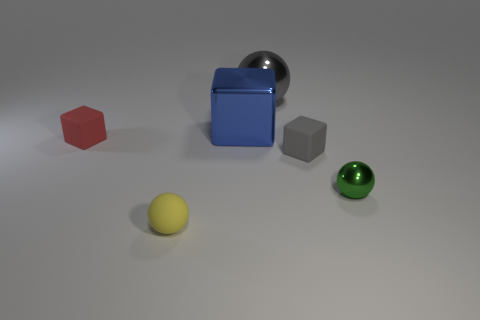What number of big blue objects are right of the matte ball?
Your answer should be very brief. 1. Is there a tiny cyan cylinder that has the same material as the tiny green thing?
Your answer should be very brief. No. There is a yellow sphere that is the same size as the green sphere; what is its material?
Your answer should be compact. Rubber. There is a ball that is in front of the large gray object and behind the yellow thing; what size is it?
Provide a succinct answer. Small. What color is the small object that is both in front of the tiny red rubber thing and left of the big blue block?
Ensure brevity in your answer.  Yellow. Is the number of small balls that are to the left of the big ball less than the number of small red matte things behind the small shiny thing?
Give a very brief answer. No. How many other gray rubber objects have the same shape as the big gray thing?
Ensure brevity in your answer.  0. What is the size of the red block that is made of the same material as the small gray block?
Your answer should be very brief. Small. What is the color of the block on the right side of the big gray metallic thing that is behind the red thing?
Provide a short and direct response. Gray. Does the green metal object have the same shape as the tiny matte thing that is left of the small rubber sphere?
Make the answer very short. No. 